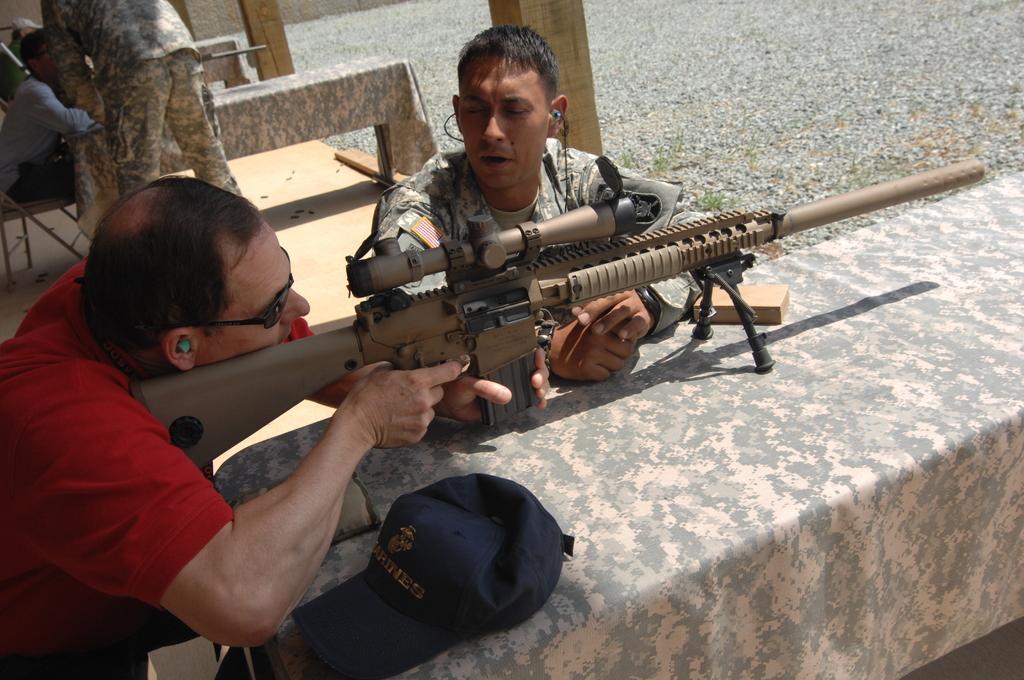How would you summarize this image in a sentence or two? In the picture we can see a man holding a gun and aiming at something he is in a red T-shirt and beside him we can see an army person in a uniform and beside them, we can see an army person standing near the bench and showing something to the person holding a gun. 